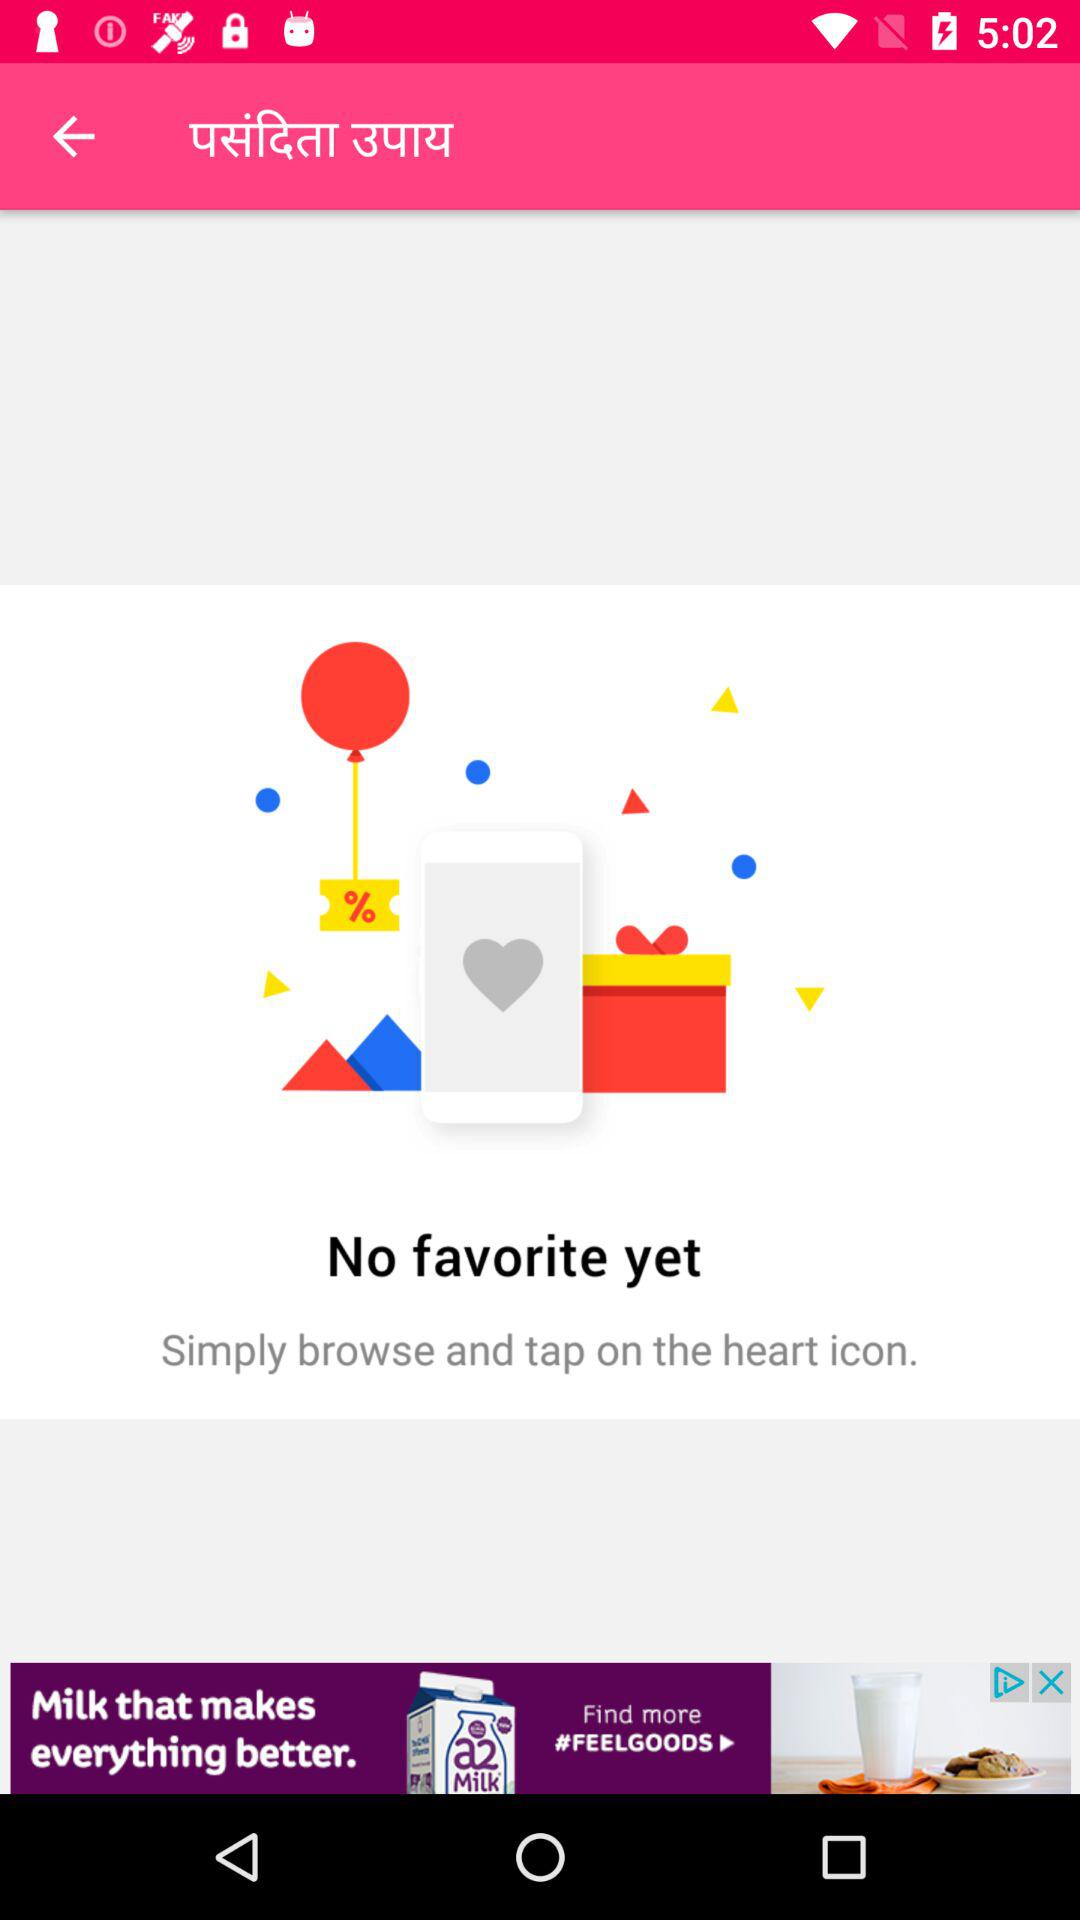Are there any favorites? There are no favorites. 